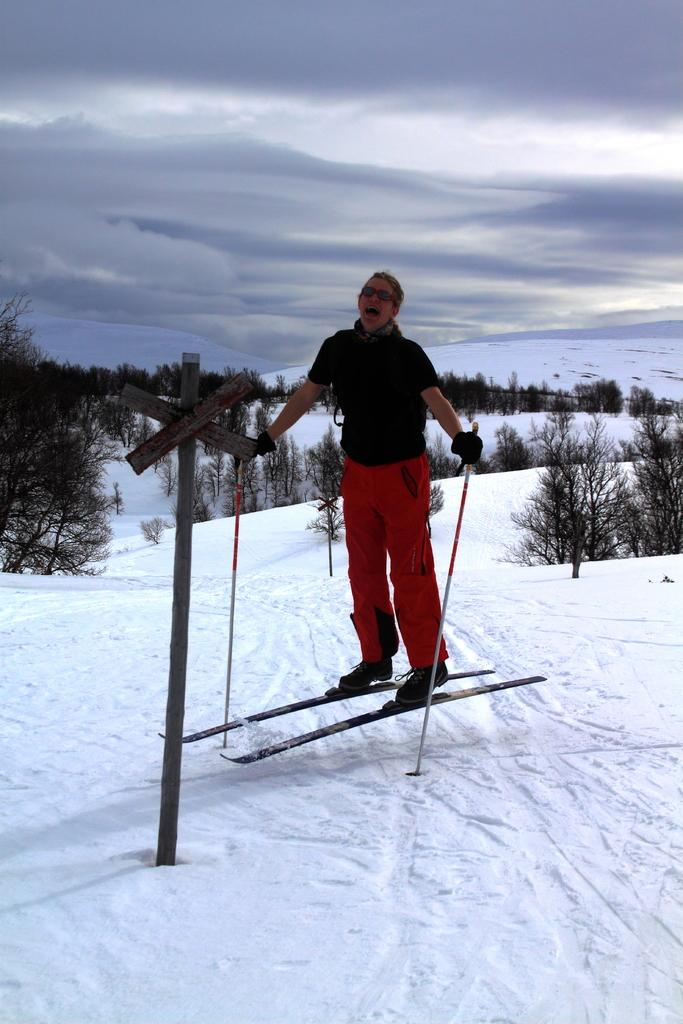What type of vegetation can be seen in the image? There are trees in the image. What is the weather like in the image? There is snow in the image, indicating a cold and likely wintery environment. What can be seen in the sky in the image? The sky is visible in the image, and clouds are present. What is the woman in the image doing? The woman is holding sticks in her hands and standing on a skiing board. What type of vein is visible on the woman's forehead in the image? There is no visible vein on the woman's forehead in the image. What emotion is the woman expressing towards the photographer in the image? The image does not provide enough information to determine the woman's emotions or feelings towards the photographer. 